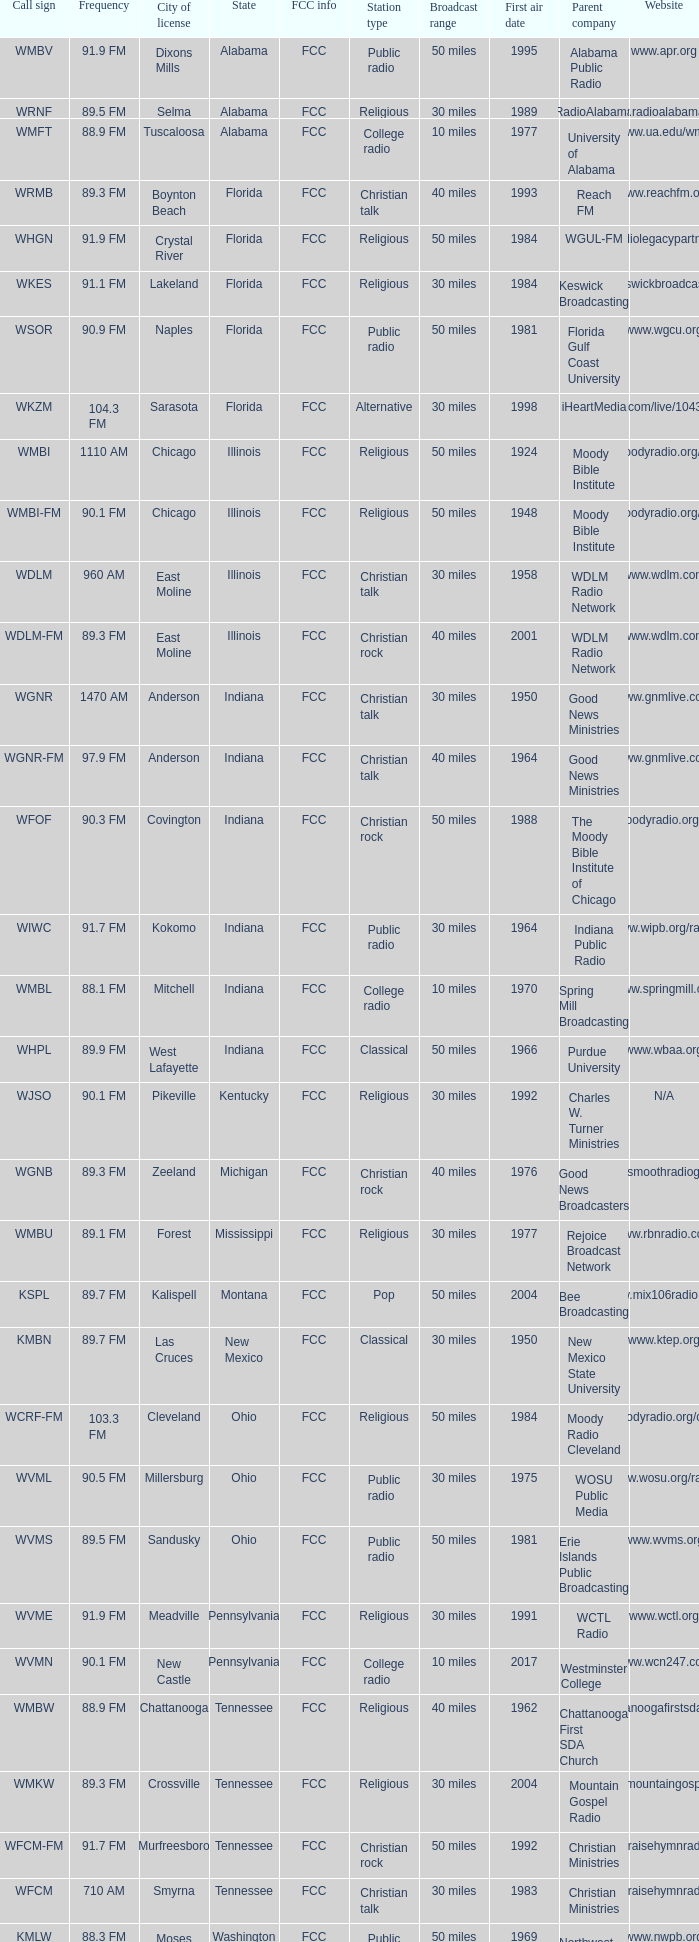9 fm that is in florida? WSOR. 